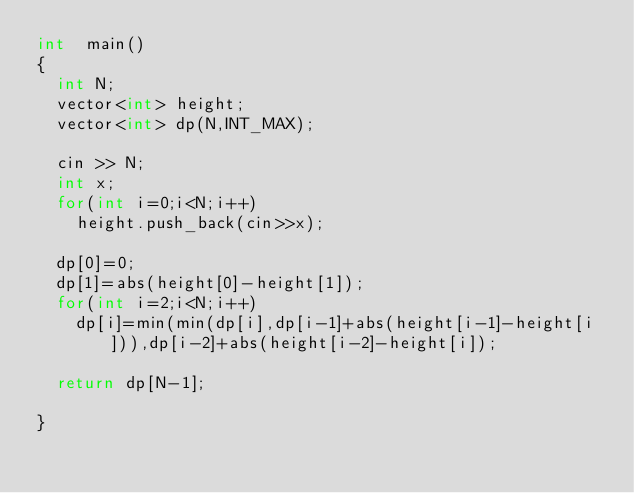<code> <loc_0><loc_0><loc_500><loc_500><_C++_>int  main()
{
  int N;
  vector<int> height;
  vector<int> dp(N,INT_MAX);
  
  cin >> N;
  int x;
  for(int i=0;i<N;i++)
    height.push_back(cin>>x);
  
  dp[0]=0;
  dp[1]=abs(height[0]-height[1]);
  for(int i=2;i<N;i++)
    dp[i]=min(min(dp[i],dp[i-1]+abs(height[i-1]-height[i])),dp[i-2]+abs(height[i-2]-height[i]);

  return dp[N-1];
  
}</code> 